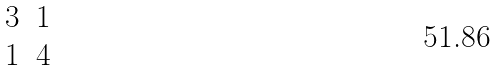<formula> <loc_0><loc_0><loc_500><loc_500>\begin{matrix} 3 & 1 \\ 1 & 4 \end{matrix}</formula> 